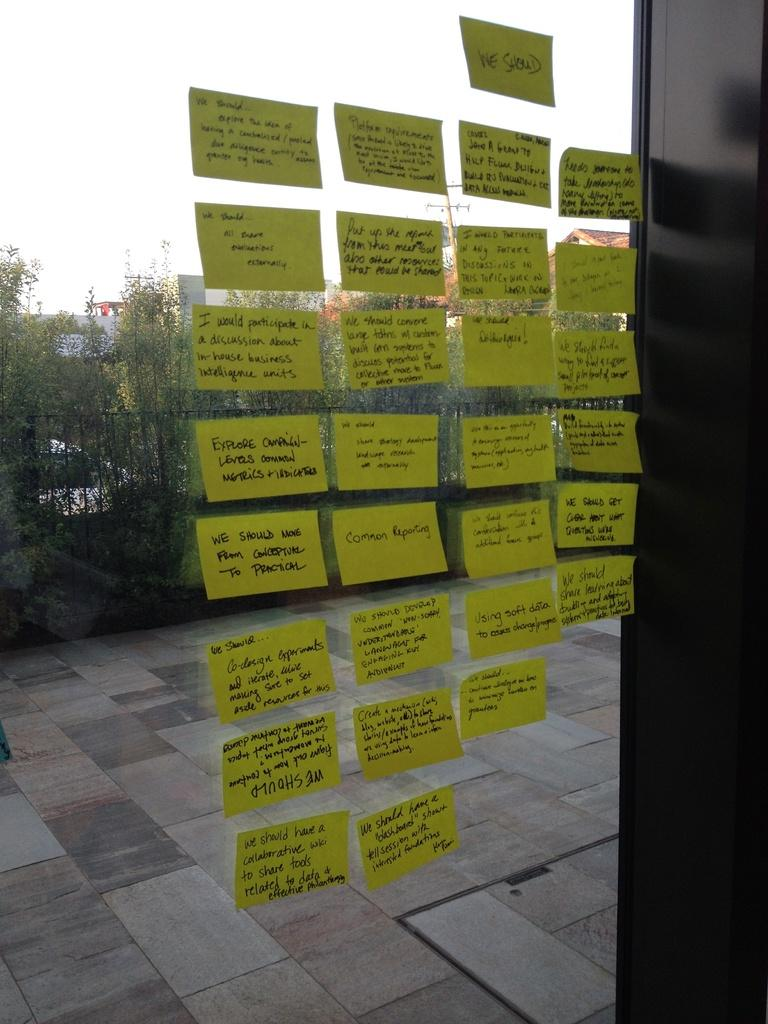What type of objects with text can be seen in the image? There are paper pieces with text in the image. What else can be seen in the image besides the paper pieces? There are plants visible in the image. What type of fang can be seen in the image? There is no fang present in the image. How does the cream appear in the image? There is no cream present in the image. 